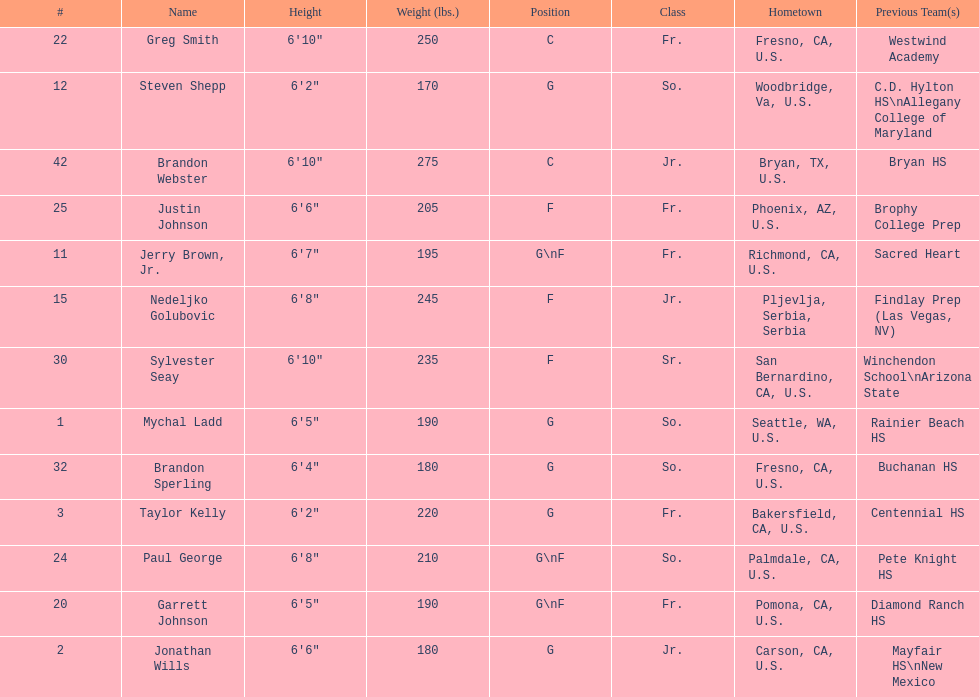Who is the next heaviest player after nedelijko golubovic? Sylvester Seay. 